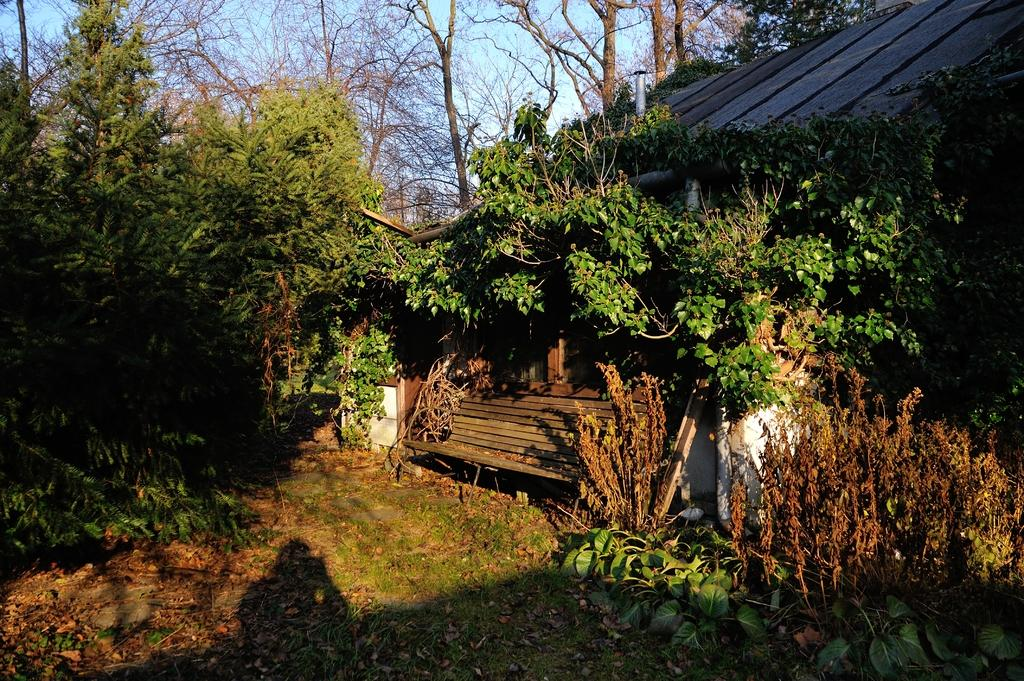What type of vegetation can be seen in the image? There are trees in the image. What type of structure is present in the image? There is a shed in the image. What type of seating is available in the image? There is a bench in the image. What type of ground cover can be seen in the image? There are plants on the ground in the image. What is the rate of the pies being sold in the image? There are no pies present in the image, so it is not possible to determine a rate of sale. What type of amusement can be seen in the image? There is no amusement present in the image; it features trees, a shed, a bench, and plants on the ground. 